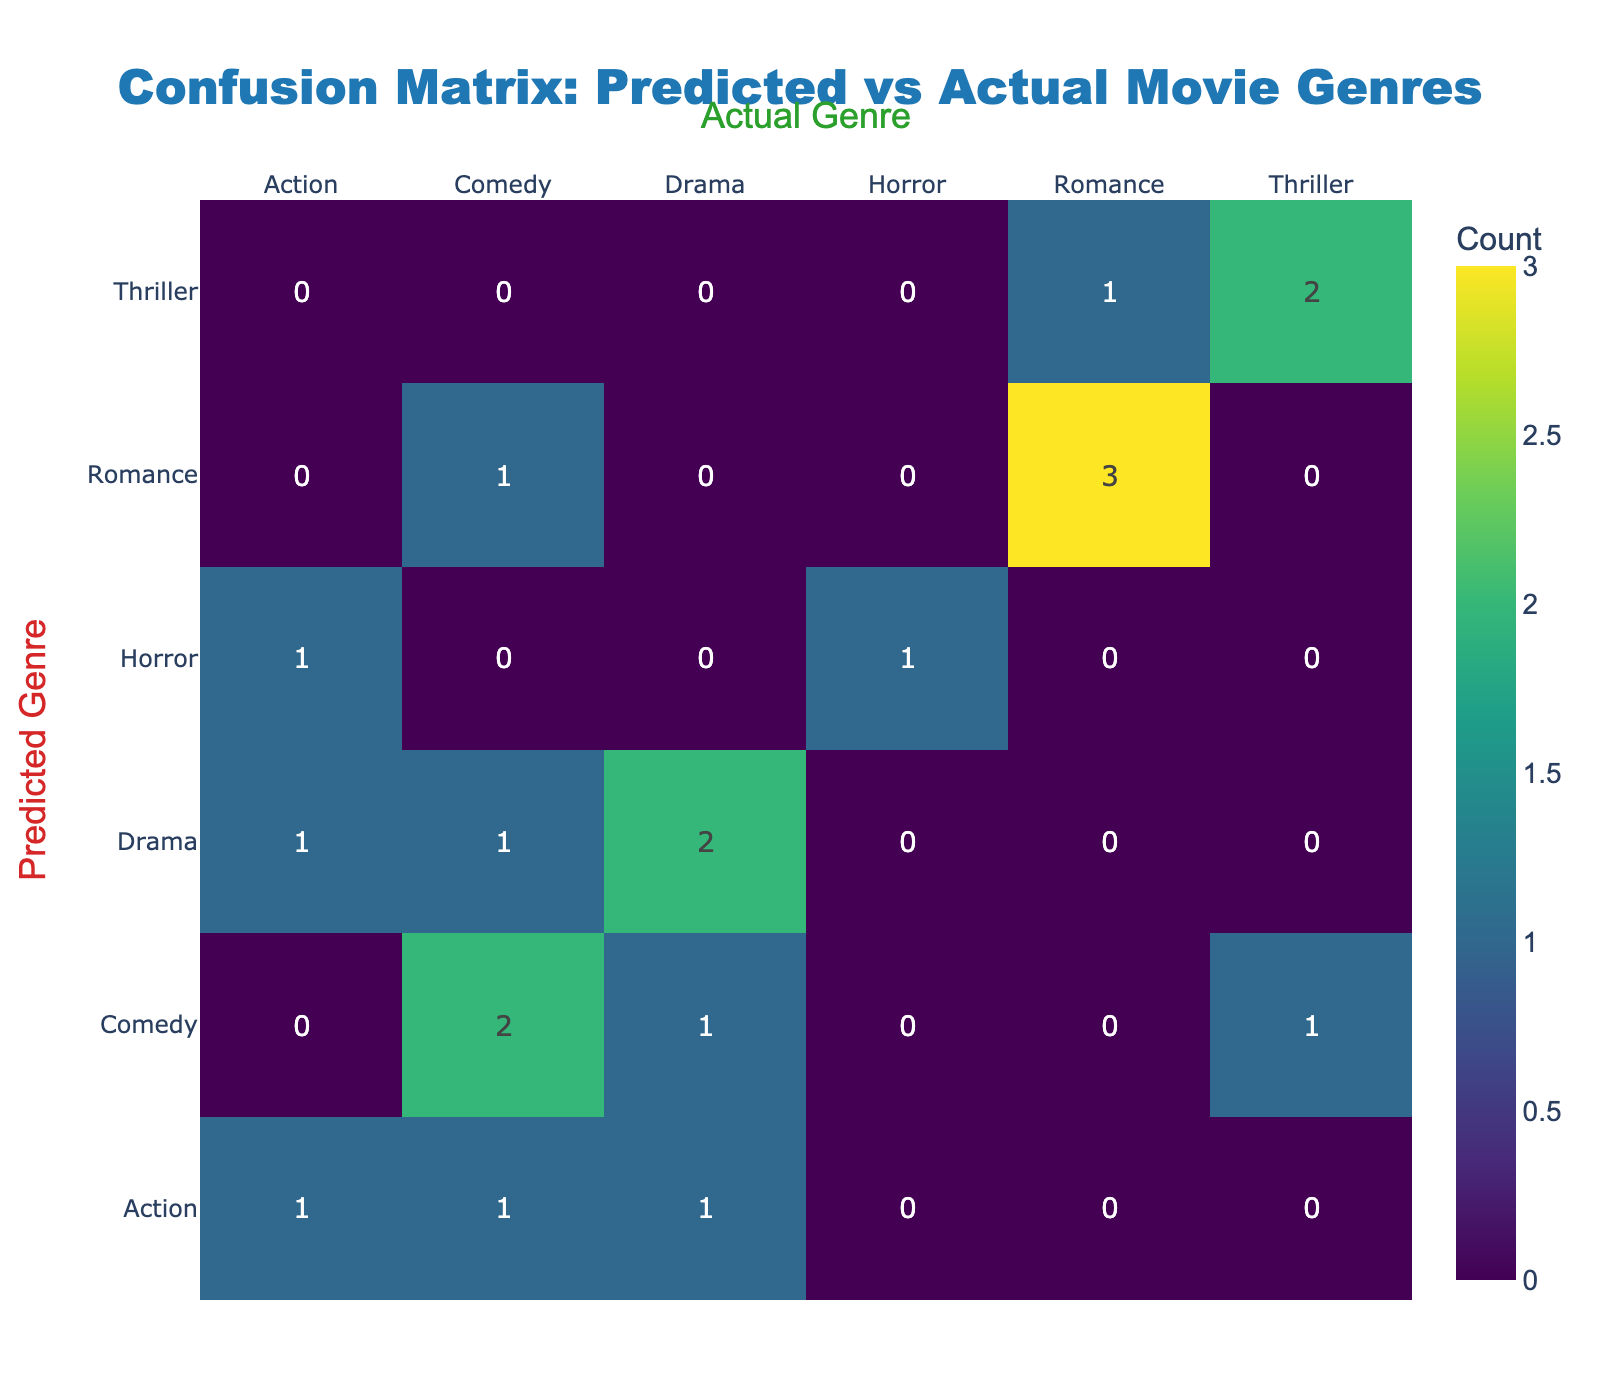What is the predicted genre of the largest number of movies? By examining the columns in the confusion matrix, we can look for the row with the highest sum across all genres. Counting each predicted genre reveals that 'Drama' is predicted for 6 movies, which is the highest count.
Answer: Drama How many movies are predicted as Action? We can look at the row labeled 'Action' and see the counts corresponding to each actual genre. There are 3 instances where 'Action' is predicted (1 Drama, 1 Comedy, and 1 Action). Summing these gives a total of 3.
Answer: 3 True or False: There were two instances of Comedy being predicted for Horror. By looking at the table, we see that there are no cells under the 'Horror' column in the 'Comedy' row. Therefore, this statement is false.
Answer: False What is the total number of movies predicted as Romance? Checking the 'Romance' row, we see there are 4 instances: 2 Romance/Drama, 1 Comedy, and 1 Romance. Adding these together gives a total of 4.
Answer: 4 How does the number of predicted Comedy movies compare to the number of predicted Thriller movies? After counting, we find 5 instances where 'Comedy' is predicted and 4 instances where 'Thriller' is predicted. Thus, Comedy is greater by 1.
Answer: Comedy is greater by 1 What percentage of Actual Thriller movies is predicted correctly? Looking at the 'Thriller' column, we find there are 3 actual Thriller movies and 3 correctly predicted (True Positive in the table). Therefore, the percentage is (3/3) * 100% = 100%.
Answer: 100% How many more Drama movies are predicted than Horror movies? 'Drama' has 6 predictions while 'Horror' has only 2. Subtracting these gives 6 - 2 = 4.
Answer: 4 What genre shows the most disagreement between predicted and actual? The rows that show the most disagreement can be identified by assessing which genres have higher off-diagonal values. In the 'Comedy' row versus other genres, there are notable discrepancies. The maximum off-diagonal values here suggest high disagreement.
Answer: Comedy What is the overall accuracy of the predictions based on the confusion matrix? Accuracy is calculated by adding the True Positives (the diagonal values) and dividing by the total number of predictions. The sum of the diagonal values (True Positives) gives 12 and the total number of entries is 20. Thus, the accuracy is (12/20) * 100% = 60%.
Answer: 60% 